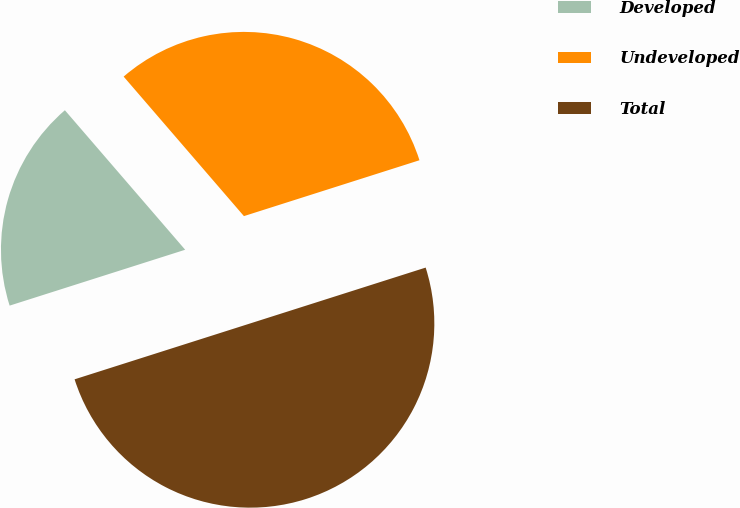<chart> <loc_0><loc_0><loc_500><loc_500><pie_chart><fcel>Developed<fcel>Undeveloped<fcel>Total<nl><fcel>18.58%<fcel>31.42%<fcel>50.0%<nl></chart> 